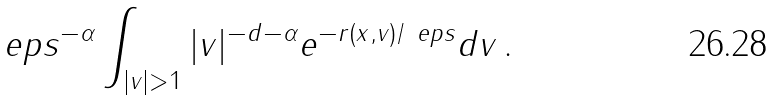Convert formula to latex. <formula><loc_0><loc_0><loc_500><loc_500>\ e p s ^ { - \alpha } \int _ { | v | > 1 } | v | ^ { - d - \alpha } e ^ { - r ( x , v ) / \ e p s } d v \, .</formula> 